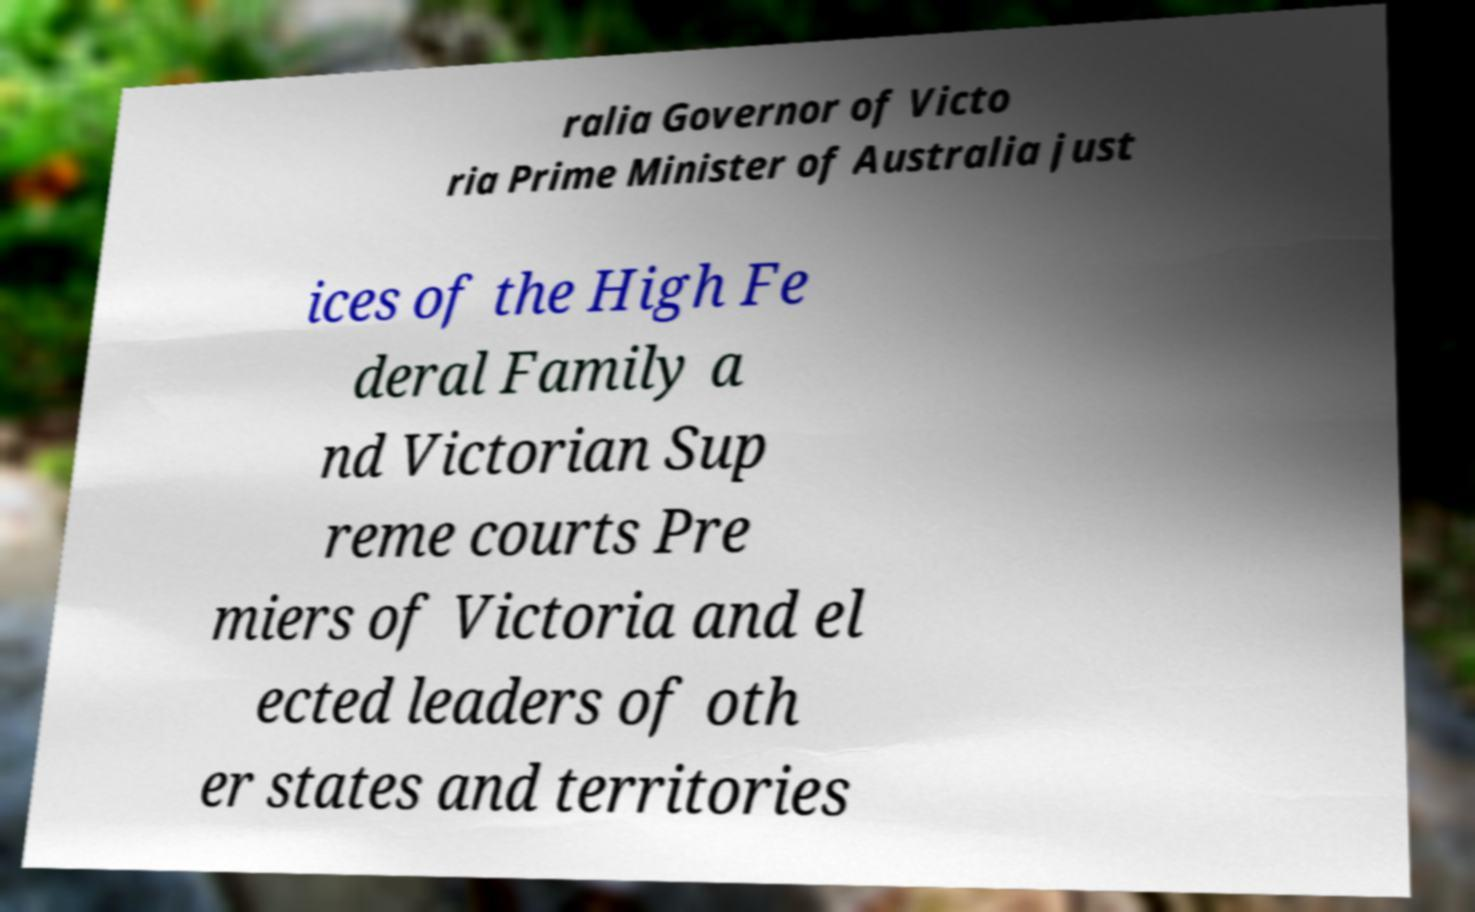Please identify and transcribe the text found in this image. ralia Governor of Victo ria Prime Minister of Australia just ices of the High Fe deral Family a nd Victorian Sup reme courts Pre miers of Victoria and el ected leaders of oth er states and territories 